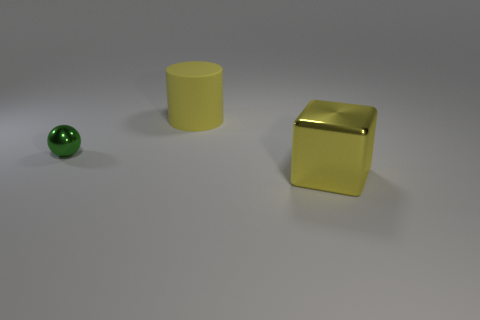Is the block the same color as the large rubber cylinder?
Provide a short and direct response. Yes. Are there any other things that are the same color as the cylinder?
Provide a succinct answer. Yes. There is a big rubber thing; is its color the same as the large object in front of the rubber object?
Make the answer very short. Yes. There is a object that is the same color as the metallic block; what size is it?
Ensure brevity in your answer.  Large. There is another object that is the same color as the matte thing; what is its material?
Give a very brief answer. Metal. Are there any big things that have the same color as the big cylinder?
Offer a very short reply. Yes. What number of objects are right of the tiny metal thing and to the left of the large metal cube?
Your answer should be very brief. 1. Is the number of big metal blocks that are behind the yellow metal thing less than the number of yellow things in front of the green metal object?
Your answer should be very brief. Yes. What number of other things are the same size as the rubber cylinder?
Offer a terse response. 1. How many objects are big yellow rubber cylinders to the left of the large yellow block or yellow objects that are behind the tiny ball?
Offer a very short reply. 1. 